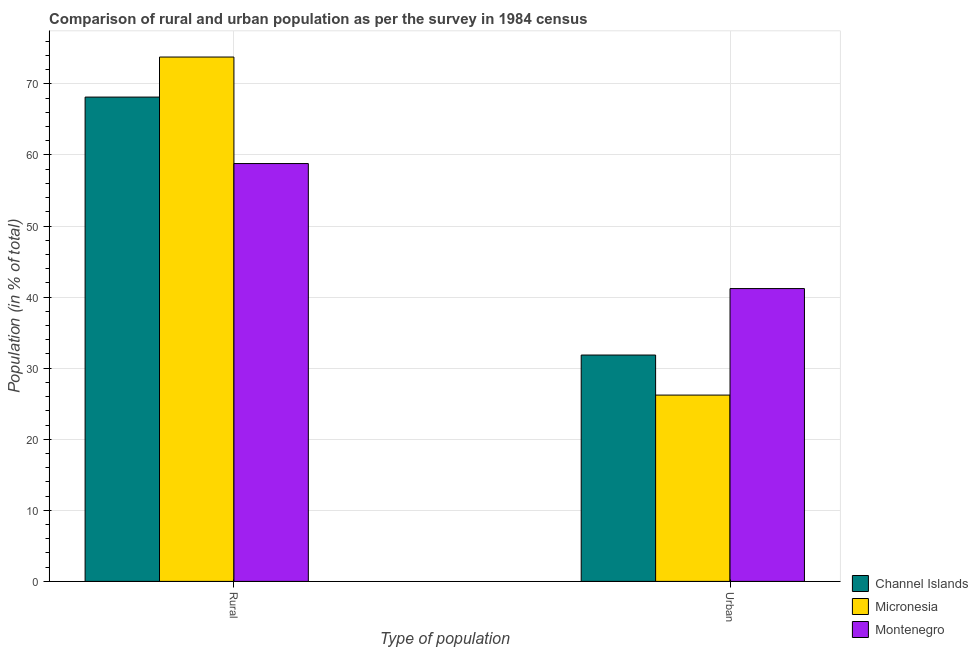How many different coloured bars are there?
Provide a succinct answer. 3. How many groups of bars are there?
Give a very brief answer. 2. Are the number of bars on each tick of the X-axis equal?
Your answer should be very brief. Yes. How many bars are there on the 1st tick from the left?
Provide a succinct answer. 3. How many bars are there on the 2nd tick from the right?
Keep it short and to the point. 3. What is the label of the 2nd group of bars from the left?
Keep it short and to the point. Urban. What is the urban population in Channel Islands?
Your response must be concise. 31.85. Across all countries, what is the maximum rural population?
Offer a very short reply. 73.78. Across all countries, what is the minimum rural population?
Provide a succinct answer. 58.8. In which country was the rural population maximum?
Give a very brief answer. Micronesia. In which country was the rural population minimum?
Ensure brevity in your answer.  Montenegro. What is the total urban population in the graph?
Your answer should be very brief. 99.27. What is the difference between the urban population in Montenegro and that in Micronesia?
Your answer should be compact. 14.99. What is the difference between the rural population in Montenegro and the urban population in Channel Islands?
Provide a short and direct response. 26.95. What is the average rural population per country?
Give a very brief answer. 66.91. What is the difference between the urban population and rural population in Micronesia?
Your answer should be very brief. -47.57. What is the ratio of the urban population in Channel Islands to that in Montenegro?
Offer a terse response. 0.77. Is the urban population in Micronesia less than that in Montenegro?
Your answer should be compact. Yes. What does the 2nd bar from the left in Urban represents?
Give a very brief answer. Micronesia. What does the 3rd bar from the right in Urban represents?
Provide a short and direct response. Channel Islands. Are all the bars in the graph horizontal?
Ensure brevity in your answer.  No. How many countries are there in the graph?
Give a very brief answer. 3. What is the difference between two consecutive major ticks on the Y-axis?
Your answer should be very brief. 10. Are the values on the major ticks of Y-axis written in scientific E-notation?
Offer a very short reply. No. Does the graph contain grids?
Provide a short and direct response. Yes. Where does the legend appear in the graph?
Provide a succinct answer. Bottom right. How many legend labels are there?
Your answer should be very brief. 3. What is the title of the graph?
Ensure brevity in your answer.  Comparison of rural and urban population as per the survey in 1984 census. Does "Ukraine" appear as one of the legend labels in the graph?
Offer a very short reply. No. What is the label or title of the X-axis?
Ensure brevity in your answer.  Type of population. What is the label or title of the Y-axis?
Keep it short and to the point. Population (in % of total). What is the Population (in % of total) in Channel Islands in Rural?
Give a very brief answer. 68.15. What is the Population (in % of total) of Micronesia in Rural?
Provide a short and direct response. 73.78. What is the Population (in % of total) in Montenegro in Rural?
Offer a terse response. 58.8. What is the Population (in % of total) in Channel Islands in Urban?
Your answer should be very brief. 31.85. What is the Population (in % of total) of Micronesia in Urban?
Your response must be concise. 26.22. What is the Population (in % of total) in Montenegro in Urban?
Make the answer very short. 41.2. Across all Type of population, what is the maximum Population (in % of total) in Channel Islands?
Ensure brevity in your answer.  68.15. Across all Type of population, what is the maximum Population (in % of total) of Micronesia?
Ensure brevity in your answer.  73.78. Across all Type of population, what is the maximum Population (in % of total) of Montenegro?
Keep it short and to the point. 58.8. Across all Type of population, what is the minimum Population (in % of total) of Channel Islands?
Provide a short and direct response. 31.85. Across all Type of population, what is the minimum Population (in % of total) of Micronesia?
Make the answer very short. 26.22. Across all Type of population, what is the minimum Population (in % of total) of Montenegro?
Offer a terse response. 41.2. What is the total Population (in % of total) of Micronesia in the graph?
Offer a very short reply. 100. What is the difference between the Population (in % of total) in Channel Islands in Rural and that in Urban?
Offer a very short reply. 36.3. What is the difference between the Population (in % of total) of Micronesia in Rural and that in Urban?
Give a very brief answer. 47.57. What is the difference between the Population (in % of total) in Montenegro in Rural and that in Urban?
Offer a terse response. 17.59. What is the difference between the Population (in % of total) in Channel Islands in Rural and the Population (in % of total) in Micronesia in Urban?
Your answer should be compact. 41.93. What is the difference between the Population (in % of total) in Channel Islands in Rural and the Population (in % of total) in Montenegro in Urban?
Make the answer very short. 26.95. What is the difference between the Population (in % of total) in Micronesia in Rural and the Population (in % of total) in Montenegro in Urban?
Keep it short and to the point. 32.58. What is the average Population (in % of total) in Micronesia per Type of population?
Provide a short and direct response. 50. What is the difference between the Population (in % of total) in Channel Islands and Population (in % of total) in Micronesia in Rural?
Make the answer very short. -5.63. What is the difference between the Population (in % of total) in Channel Islands and Population (in % of total) in Montenegro in Rural?
Make the answer very short. 9.35. What is the difference between the Population (in % of total) in Micronesia and Population (in % of total) in Montenegro in Rural?
Ensure brevity in your answer.  14.99. What is the difference between the Population (in % of total) of Channel Islands and Population (in % of total) of Micronesia in Urban?
Give a very brief answer. 5.63. What is the difference between the Population (in % of total) of Channel Islands and Population (in % of total) of Montenegro in Urban?
Give a very brief answer. -9.35. What is the difference between the Population (in % of total) in Micronesia and Population (in % of total) in Montenegro in Urban?
Your answer should be very brief. -14.99. What is the ratio of the Population (in % of total) of Channel Islands in Rural to that in Urban?
Provide a short and direct response. 2.14. What is the ratio of the Population (in % of total) in Micronesia in Rural to that in Urban?
Your answer should be very brief. 2.81. What is the ratio of the Population (in % of total) of Montenegro in Rural to that in Urban?
Provide a short and direct response. 1.43. What is the difference between the highest and the second highest Population (in % of total) of Channel Islands?
Offer a terse response. 36.3. What is the difference between the highest and the second highest Population (in % of total) of Micronesia?
Your answer should be compact. 47.57. What is the difference between the highest and the second highest Population (in % of total) of Montenegro?
Provide a short and direct response. 17.59. What is the difference between the highest and the lowest Population (in % of total) of Channel Islands?
Offer a very short reply. 36.3. What is the difference between the highest and the lowest Population (in % of total) of Micronesia?
Provide a short and direct response. 47.57. What is the difference between the highest and the lowest Population (in % of total) in Montenegro?
Give a very brief answer. 17.59. 